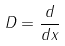Convert formula to latex. <formula><loc_0><loc_0><loc_500><loc_500>D = \frac { d } { d x }</formula> 